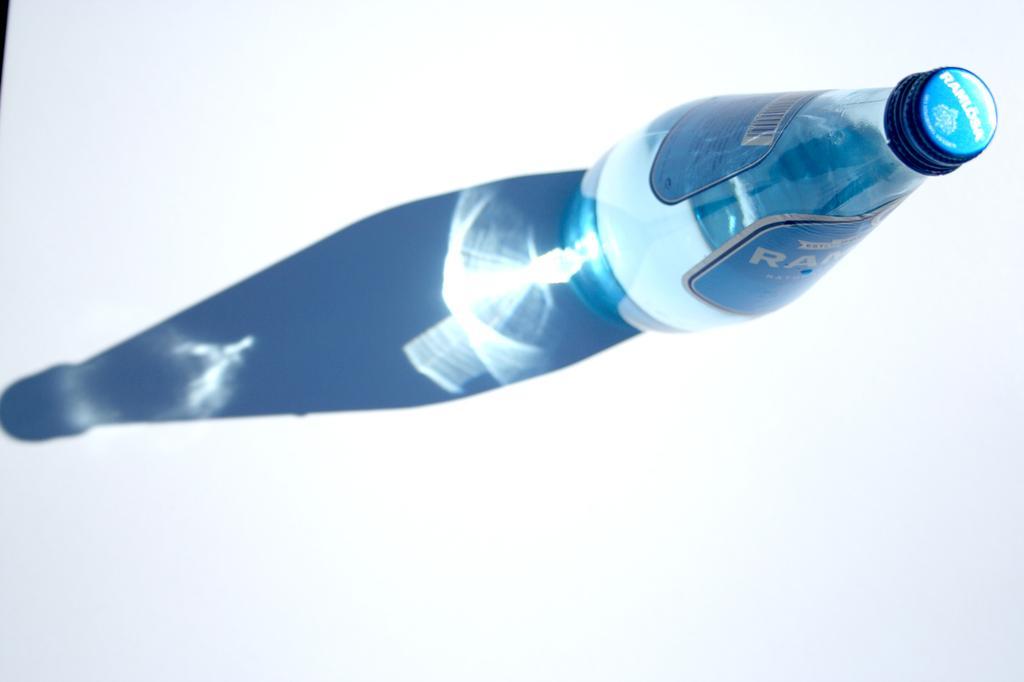Please provide a concise description of this image. This picture shows a bottle placed on the table and a shadow of the bottle. 